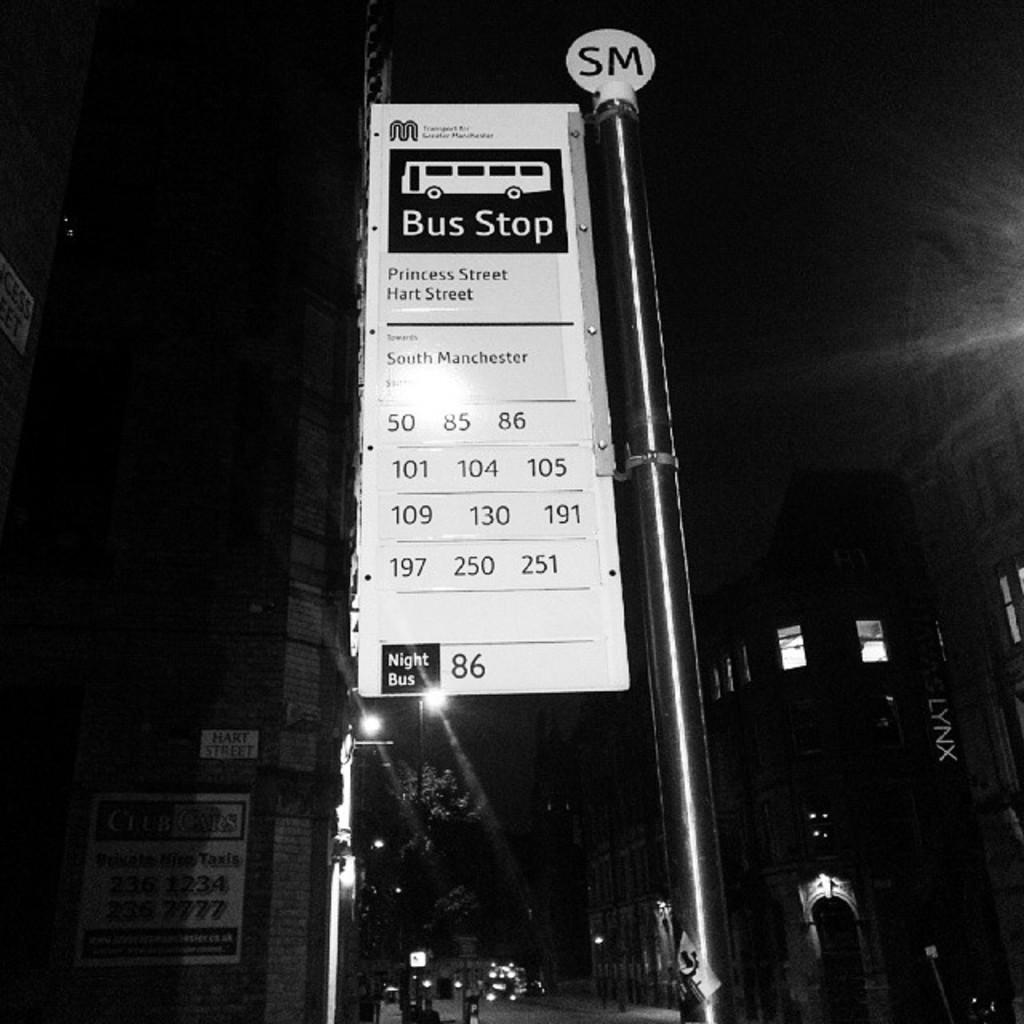What is the main object in the image? There is a pole in the image. What is attached to the pole? There are boards on the pole. What can be seen in the background of the image? The background of the image includes buildings, trees, lights, and windows. Where are the boards located on the pole? The boards are on a wall. What type of needle is being used to sew the sign on the pole? There is no sign or needle present in the image; it only features a pole with boards on a wall. 